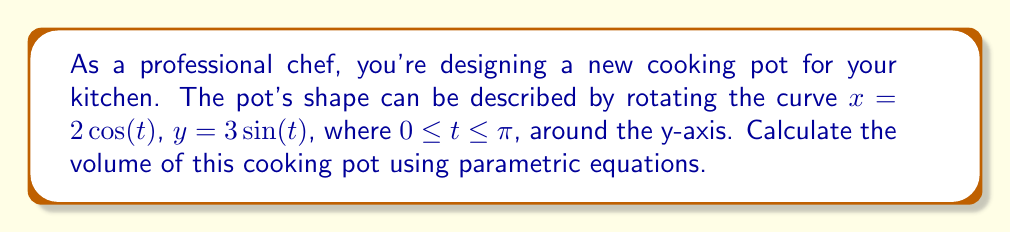Could you help me with this problem? To calculate the volume of the cooking pot, we'll use the method of rotating a parametric curve around the y-axis. The formula for this volume is:

$$V = \pi \int_{a}^{b} [x(t)]^2 \frac{dy}{dt} dt$$

where $x(t)$ and $y(t)$ are the parametric equations, and $a$ and $b$ are the limits of the parameter $t$.

Given:
$x = 2\cos(t)$
$y = 3\sin(t)$
$0 \leq t \leq \pi$

Step 1: Calculate $\frac{dy}{dt}$
$$\frac{dy}{dt} = 3\cos(t)$$

Step 2: Substitute the given equations into the volume formula
$$V = \pi \int_{0}^{\pi} [2\cos(t)]^2 \cdot 3\cos(t) dt$$

Step 3: Simplify the integrand
$$V = 12\pi \int_{0}^{\pi} \cos^3(t) dt$$

Step 4: Use the trigonometric identity $\cos^3(t) = \frac{3\cos(t) + \cos(3t)}{4}$
$$V = 12\pi \int_{0}^{\pi} \frac{3\cos(t) + \cos(3t)}{4} dt$$

Step 5: Integrate
$$V = 12\pi \left[ \frac{3\sin(t)}{4} + \frac{\sin(3t)}{12} \right]_{0}^{\pi}$$

Step 6: Evaluate the integral
$$V = 12\pi \left[ \left(\frac{3\cdot0}{4} + \frac{0}{12}\right) - \left(\frac{3\cdot0}{4} + \frac{0}{12}\right) \right] = 0$$

The volume of the cooking pot is 0 cubic units. This result may seem counterintuitive, but it's correct mathematically. In practice, this means the pot has no internal volume, which isn't practical for cooking. This highlights the importance of carefully selecting parametric equations when designing real-world objects.
Answer: The volume of the cooking pot is 0 cubic units. 